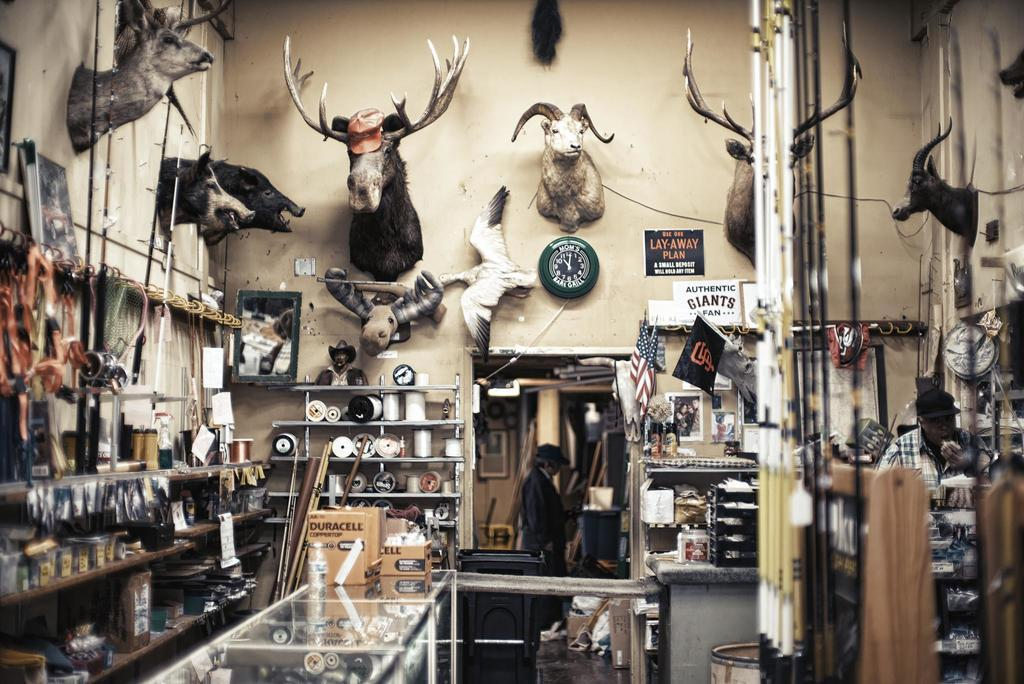<image>
Give a short and clear explanation of the subsequent image. a gun shop with a sign that reads authentic giants fan 